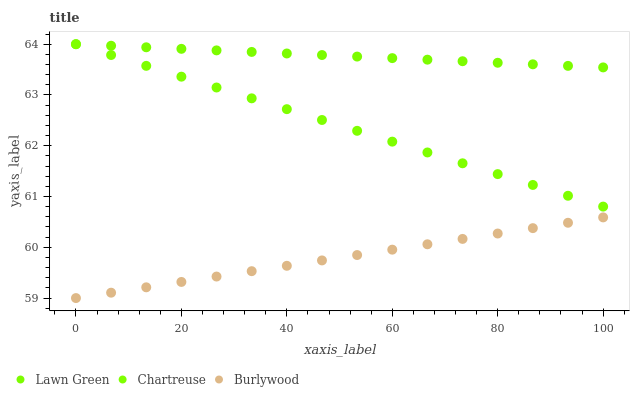Does Burlywood have the minimum area under the curve?
Answer yes or no. Yes. Does Lawn Green have the maximum area under the curve?
Answer yes or no. Yes. Does Chartreuse have the minimum area under the curve?
Answer yes or no. No. Does Chartreuse have the maximum area under the curve?
Answer yes or no. No. Is Burlywood the smoothest?
Answer yes or no. Yes. Is Lawn Green the roughest?
Answer yes or no. Yes. Is Chartreuse the smoothest?
Answer yes or no. No. Is Chartreuse the roughest?
Answer yes or no. No. Does Burlywood have the lowest value?
Answer yes or no. Yes. Does Chartreuse have the lowest value?
Answer yes or no. No. Does Chartreuse have the highest value?
Answer yes or no. Yes. Is Burlywood less than Chartreuse?
Answer yes or no. Yes. Is Lawn Green greater than Burlywood?
Answer yes or no. Yes. Does Lawn Green intersect Chartreuse?
Answer yes or no. Yes. Is Lawn Green less than Chartreuse?
Answer yes or no. No. Is Lawn Green greater than Chartreuse?
Answer yes or no. No. Does Burlywood intersect Chartreuse?
Answer yes or no. No. 